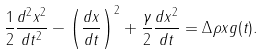Convert formula to latex. <formula><loc_0><loc_0><loc_500><loc_500>\frac { 1 } { 2 } \frac { d ^ { 2 } x ^ { 2 } } { d t ^ { 2 } } - \left ( \frac { d x } { d t } \right ) ^ { 2 } + \frac { \gamma } { 2 } \frac { d x ^ { 2 } } { d t } = \Delta \rho x g ( t ) .</formula> 